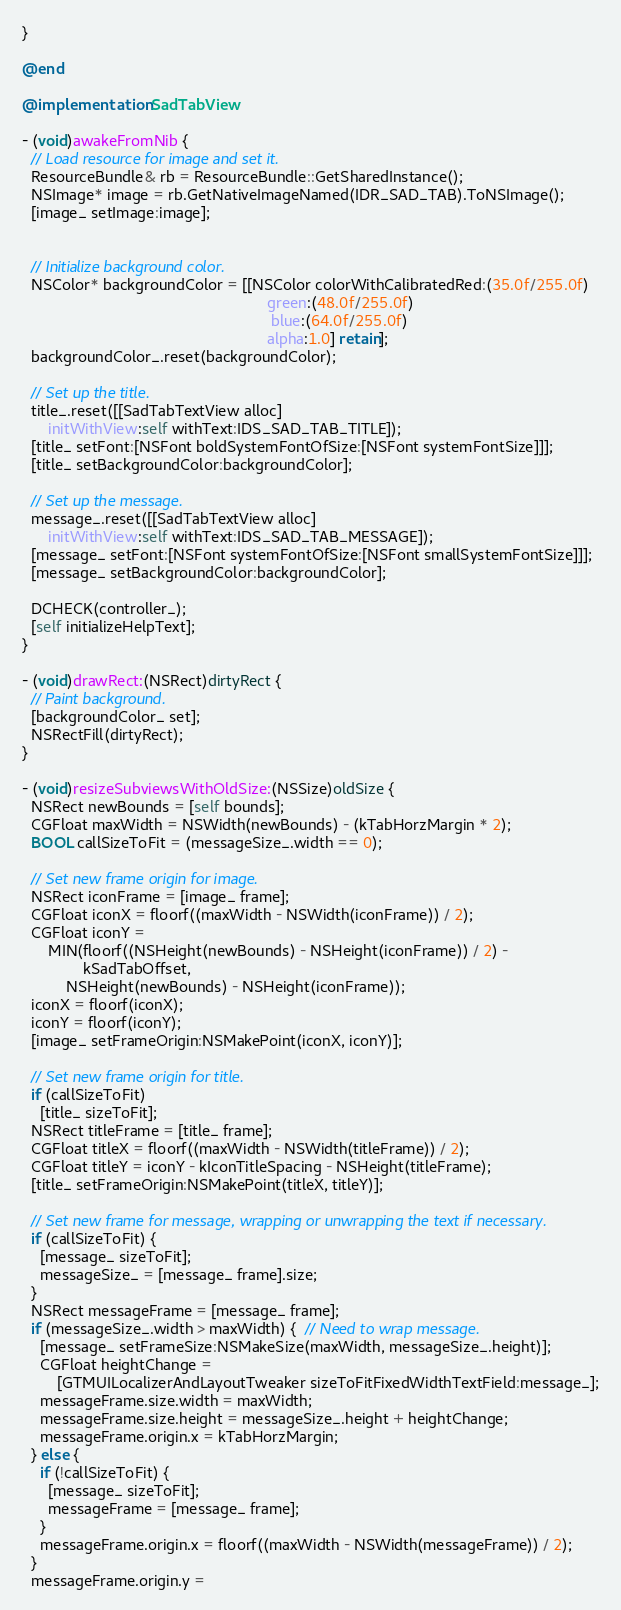Convert code to text. <code><loc_0><loc_0><loc_500><loc_500><_ObjectiveC_>}

@end

@implementation SadTabView

- (void)awakeFromNib {
  // Load resource for image and set it.
  ResourceBundle& rb = ResourceBundle::GetSharedInstance();
  NSImage* image = rb.GetNativeImageNamed(IDR_SAD_TAB).ToNSImage();
  [image_ setImage:image];


  // Initialize background color.
  NSColor* backgroundColor = [[NSColor colorWithCalibratedRed:(35.0f/255.0f)
                                                        green:(48.0f/255.0f)
                                                         blue:(64.0f/255.0f)
                                                        alpha:1.0] retain];
  backgroundColor_.reset(backgroundColor);

  // Set up the title.
  title_.reset([[SadTabTextView alloc]
      initWithView:self withText:IDS_SAD_TAB_TITLE]);
  [title_ setFont:[NSFont boldSystemFontOfSize:[NSFont systemFontSize]]];
  [title_ setBackgroundColor:backgroundColor];

  // Set up the message.
  message_.reset([[SadTabTextView alloc]
      initWithView:self withText:IDS_SAD_TAB_MESSAGE]);
  [message_ setFont:[NSFont systemFontOfSize:[NSFont smallSystemFontSize]]];
  [message_ setBackgroundColor:backgroundColor];

  DCHECK(controller_);
  [self initializeHelpText];
}

- (void)drawRect:(NSRect)dirtyRect {
  // Paint background.
  [backgroundColor_ set];
  NSRectFill(dirtyRect);
}

- (void)resizeSubviewsWithOldSize:(NSSize)oldSize {
  NSRect newBounds = [self bounds];
  CGFloat maxWidth = NSWidth(newBounds) - (kTabHorzMargin * 2);
  BOOL callSizeToFit = (messageSize_.width == 0);

  // Set new frame origin for image.
  NSRect iconFrame = [image_ frame];
  CGFloat iconX = floorf((maxWidth - NSWidth(iconFrame)) / 2);
  CGFloat iconY =
      MIN(floorf((NSHeight(newBounds) - NSHeight(iconFrame)) / 2) -
              kSadTabOffset,
          NSHeight(newBounds) - NSHeight(iconFrame));
  iconX = floorf(iconX);
  iconY = floorf(iconY);
  [image_ setFrameOrigin:NSMakePoint(iconX, iconY)];

  // Set new frame origin for title.
  if (callSizeToFit)
    [title_ sizeToFit];
  NSRect titleFrame = [title_ frame];
  CGFloat titleX = floorf((maxWidth - NSWidth(titleFrame)) / 2);
  CGFloat titleY = iconY - kIconTitleSpacing - NSHeight(titleFrame);
  [title_ setFrameOrigin:NSMakePoint(titleX, titleY)];

  // Set new frame for message, wrapping or unwrapping the text if necessary.
  if (callSizeToFit) {
    [message_ sizeToFit];
    messageSize_ = [message_ frame].size;
  }
  NSRect messageFrame = [message_ frame];
  if (messageSize_.width > maxWidth) {  // Need to wrap message.
    [message_ setFrameSize:NSMakeSize(maxWidth, messageSize_.height)];
    CGFloat heightChange =
        [GTMUILocalizerAndLayoutTweaker sizeToFitFixedWidthTextField:message_];
    messageFrame.size.width = maxWidth;
    messageFrame.size.height = messageSize_.height + heightChange;
    messageFrame.origin.x = kTabHorzMargin;
  } else {
    if (!callSizeToFit) {
      [message_ sizeToFit];
      messageFrame = [message_ frame];
    }
    messageFrame.origin.x = floorf((maxWidth - NSWidth(messageFrame)) / 2);
  }
  messageFrame.origin.y =</code> 